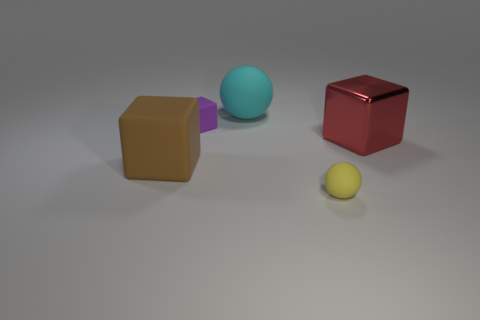Add 1 yellow rubber balls. How many objects exist? 6 Subtract all spheres. How many objects are left? 3 Add 3 small balls. How many small balls exist? 4 Subtract 0 blue cylinders. How many objects are left? 5 Subtract all big red cubes. Subtract all large cyan matte balls. How many objects are left? 3 Add 1 cyan rubber objects. How many cyan rubber objects are left? 2 